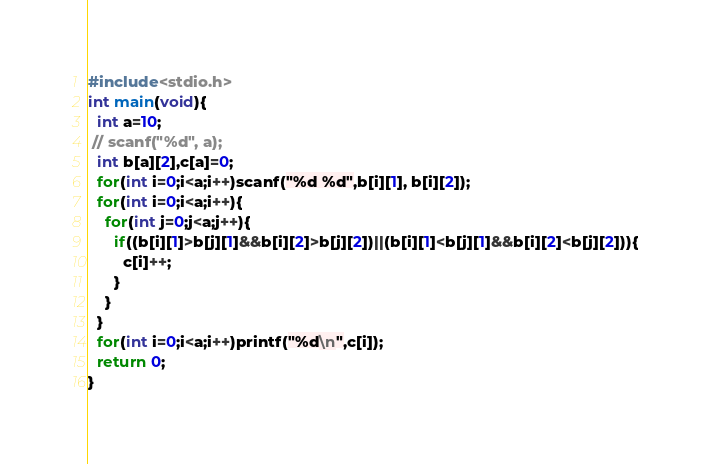Convert code to text. <code><loc_0><loc_0><loc_500><loc_500><_C_>#include<stdio.h>
int main(void){
  int a=10;
 // scanf("%d", a);
  int b[a][2],c[a]=0;
  for(int i=0;i<a;i++)scanf("%d %d",b[i][1], b[i][2]);
  for(int i=0;i<a;i++){
    for(int j=0;j<a;j++){
      if((b[i][1]>b[j][1]&&b[i][2]>b[j][2])||(b[i][1]<b[j][1]&&b[i][2]<b[j][2])){
        c[i]++;
      }
    }
  }
  for(int i=0;i<a;i++)printf("%d\n",c[i]);
  return 0;
}</code> 